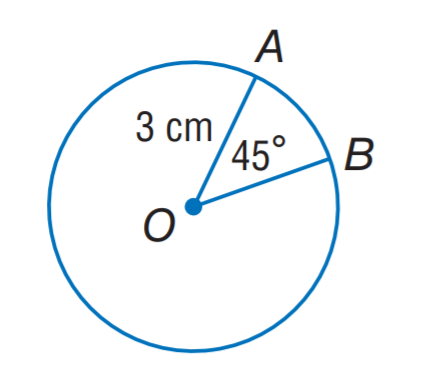Answer the mathemtical geometry problem and directly provide the correct option letter.
Question: Find the length of \widehat A B. Round to the nearest hundredth.
Choices: A: 1.18 B: 2.36 C: 3.36 D: 4.72 B 